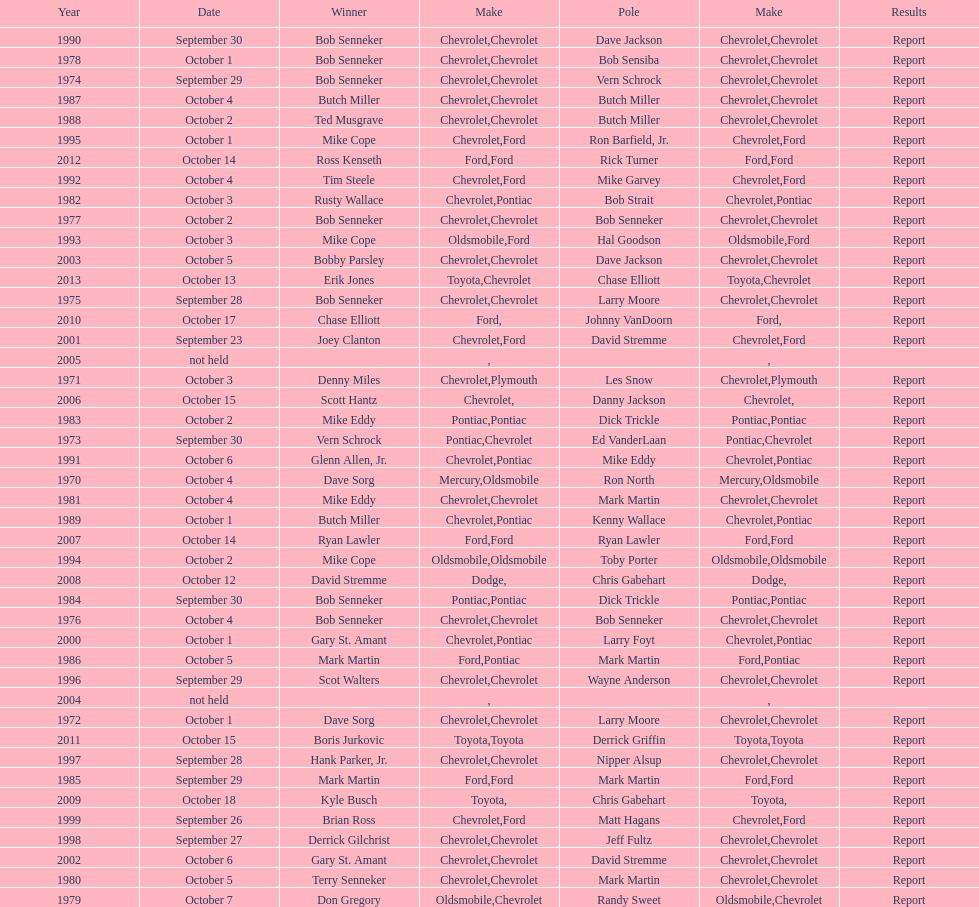What make of car had the fewest victories in races? Toyota. 